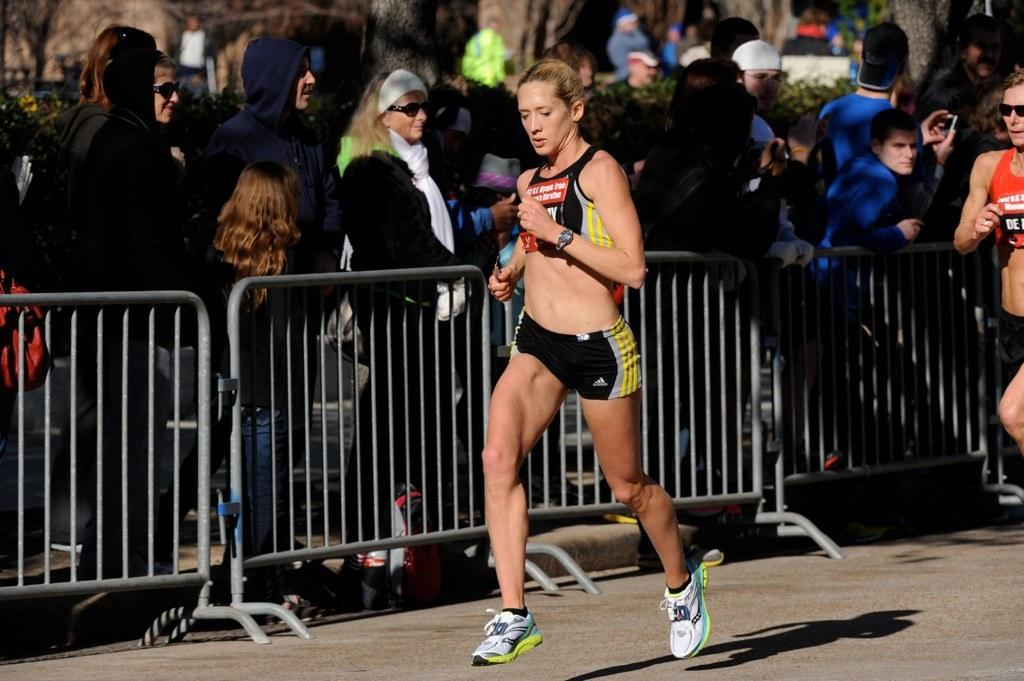How many women are in the image? There are two women in the image. What are the women doing in the image? The women are running on the road. What can be seen in the background of the image? There is railing, people, plants, and trees in the background of the image. What grade is the school building in the image? There is no school building present in the image. What type of transport is available for the women in the image? The image does not show any transport options for the women; they are running on the road. 